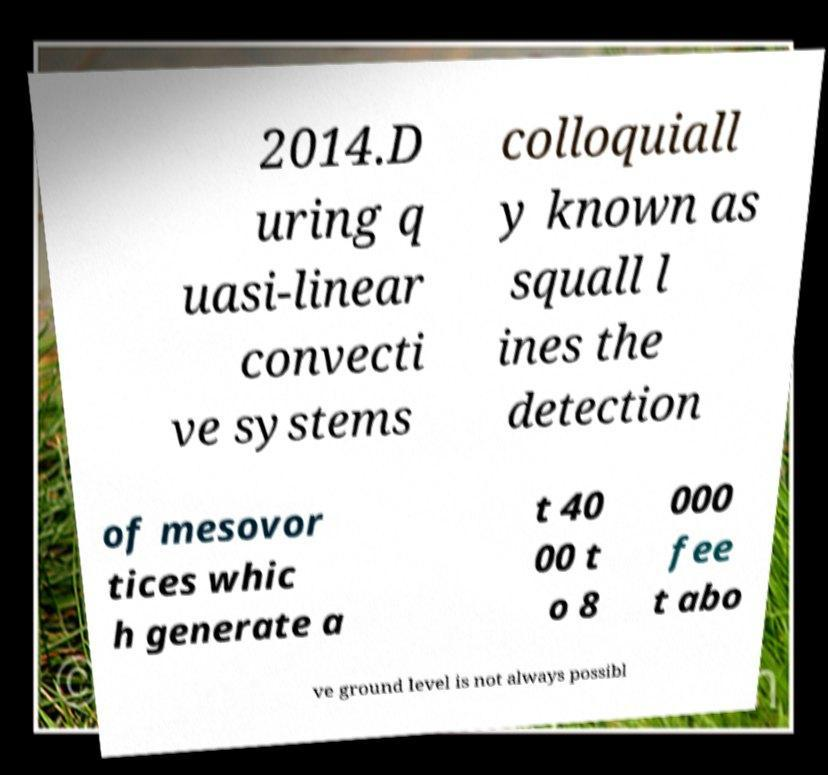Could you extract and type out the text from this image? 2014.D uring q uasi-linear convecti ve systems colloquiall y known as squall l ines the detection of mesovor tices whic h generate a t 40 00 t o 8 000 fee t abo ve ground level is not always possibl 